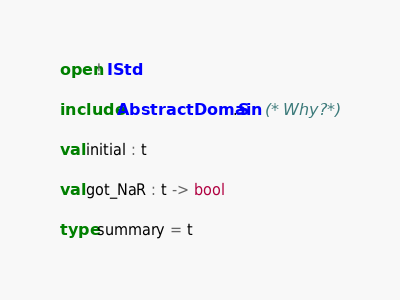<code> <loc_0><loc_0><loc_500><loc_500><_OCaml_>open! IStd

include AbstractDomain.S	(* Why? *)

val initial : t

val got_NaR : t -> bool

type summary = t</code> 